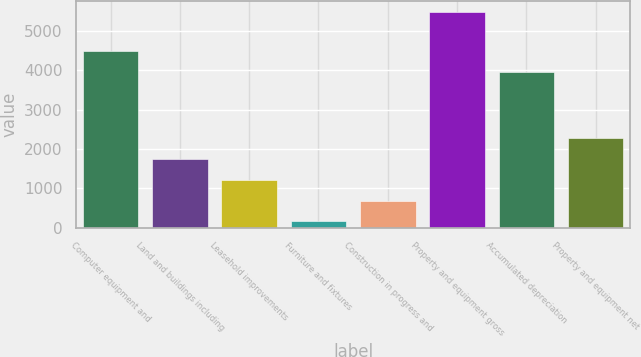Convert chart to OTSL. <chart><loc_0><loc_0><loc_500><loc_500><bar_chart><fcel>Computer equipment and<fcel>Land and buildings including<fcel>Leasehold improvements<fcel>Furniture and fixtures<fcel>Construction in progress and<fcel>Property and equipment gross<fcel>Accumulated depreciation<fcel>Property and equipment net<nl><fcel>4500.7<fcel>1755.1<fcel>1222.4<fcel>157<fcel>689.7<fcel>5484<fcel>3968<fcel>2287.8<nl></chart> 